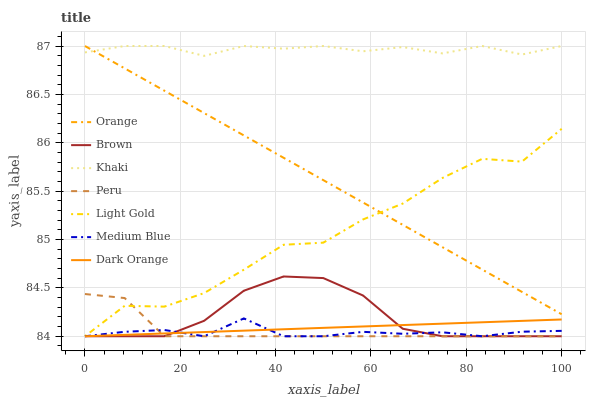Does Medium Blue have the minimum area under the curve?
Answer yes or no. Yes. Does Khaki have the maximum area under the curve?
Answer yes or no. Yes. Does Dark Orange have the minimum area under the curve?
Answer yes or no. No. Does Dark Orange have the maximum area under the curve?
Answer yes or no. No. Is Orange the smoothest?
Answer yes or no. Yes. Is Light Gold the roughest?
Answer yes or no. Yes. Is Khaki the smoothest?
Answer yes or no. No. Is Khaki the roughest?
Answer yes or no. No. Does Brown have the lowest value?
Answer yes or no. Yes. Does Khaki have the lowest value?
Answer yes or no. No. Does Orange have the highest value?
Answer yes or no. Yes. Does Dark Orange have the highest value?
Answer yes or no. No. Is Dark Orange less than Orange?
Answer yes or no. Yes. Is Orange greater than Medium Blue?
Answer yes or no. Yes. Does Medium Blue intersect Brown?
Answer yes or no. Yes. Is Medium Blue less than Brown?
Answer yes or no. No. Is Medium Blue greater than Brown?
Answer yes or no. No. Does Dark Orange intersect Orange?
Answer yes or no. No. 